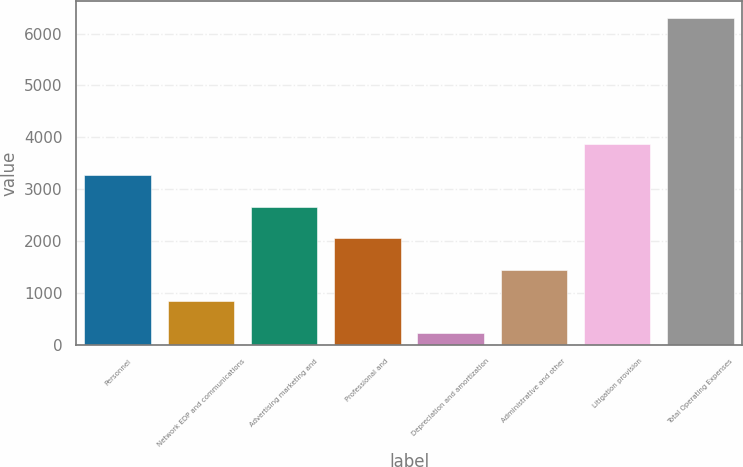Convert chart to OTSL. <chart><loc_0><loc_0><loc_500><loc_500><bar_chart><fcel>Personnel<fcel>Network EDP and communications<fcel>Advertising marketing and<fcel>Professional and<fcel>Depreciation and amortization<fcel>Administrative and other<fcel>Litigation provision<fcel>Total Operating Expenses<nl><fcel>3268.5<fcel>836.1<fcel>2660.4<fcel>2052.3<fcel>228<fcel>1444.2<fcel>3876.6<fcel>6309<nl></chart> 